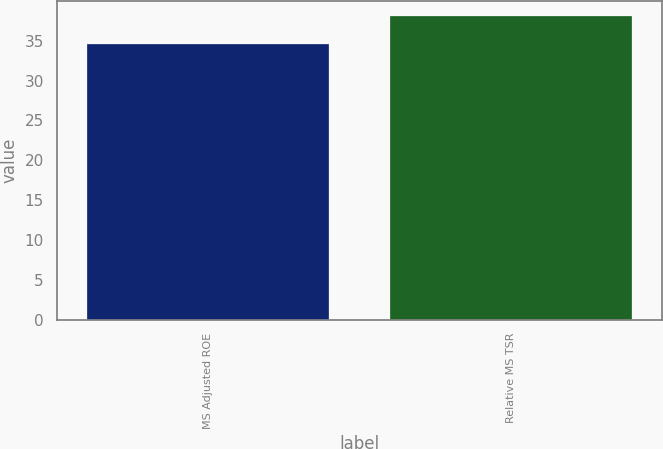<chart> <loc_0><loc_0><loc_500><loc_500><bar_chart><fcel>MS Adjusted ROE<fcel>Relative MS TSR<nl><fcel>34.58<fcel>38.07<nl></chart> 